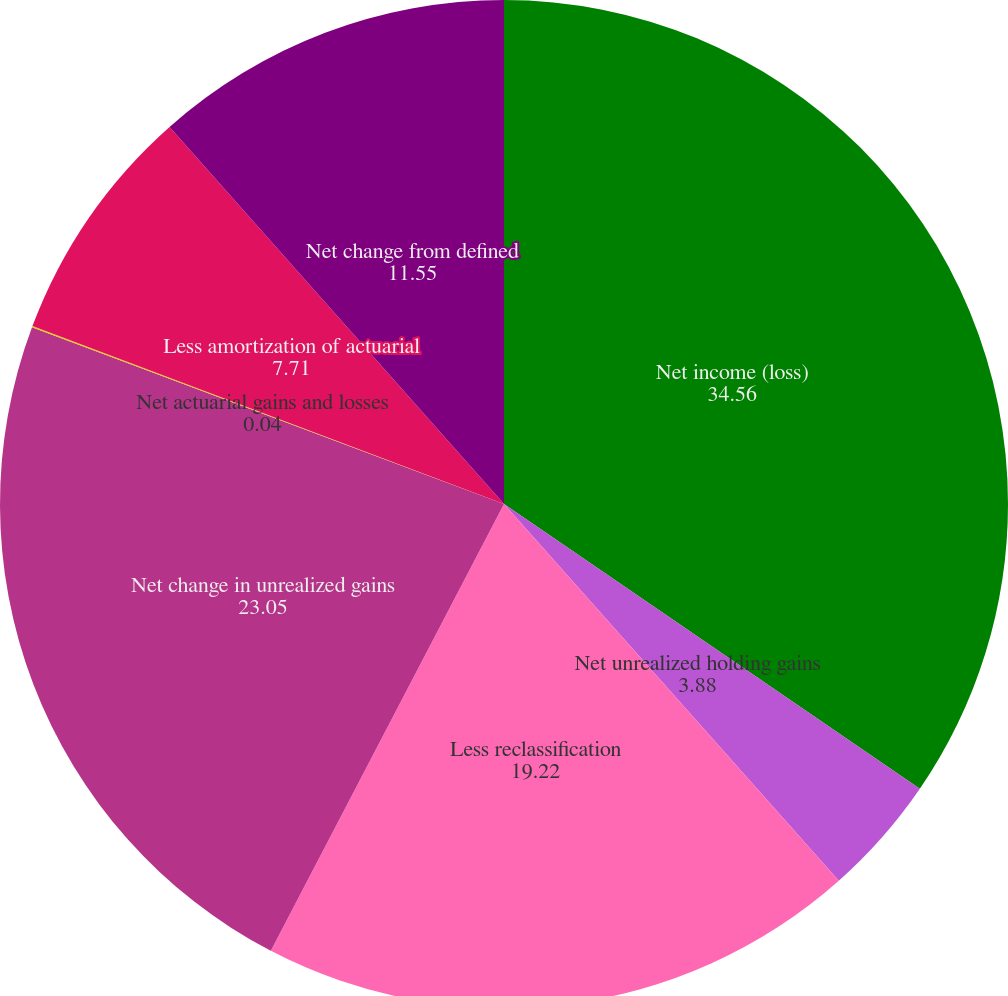Convert chart to OTSL. <chart><loc_0><loc_0><loc_500><loc_500><pie_chart><fcel>Net income (loss)<fcel>Net unrealized holding gains<fcel>Less reclassification<fcel>Net change in unrealized gains<fcel>Net actuarial gains and losses<fcel>Less amortization of actuarial<fcel>Net change from defined<nl><fcel>34.56%<fcel>3.88%<fcel>19.22%<fcel>23.05%<fcel>0.04%<fcel>7.71%<fcel>11.55%<nl></chart> 